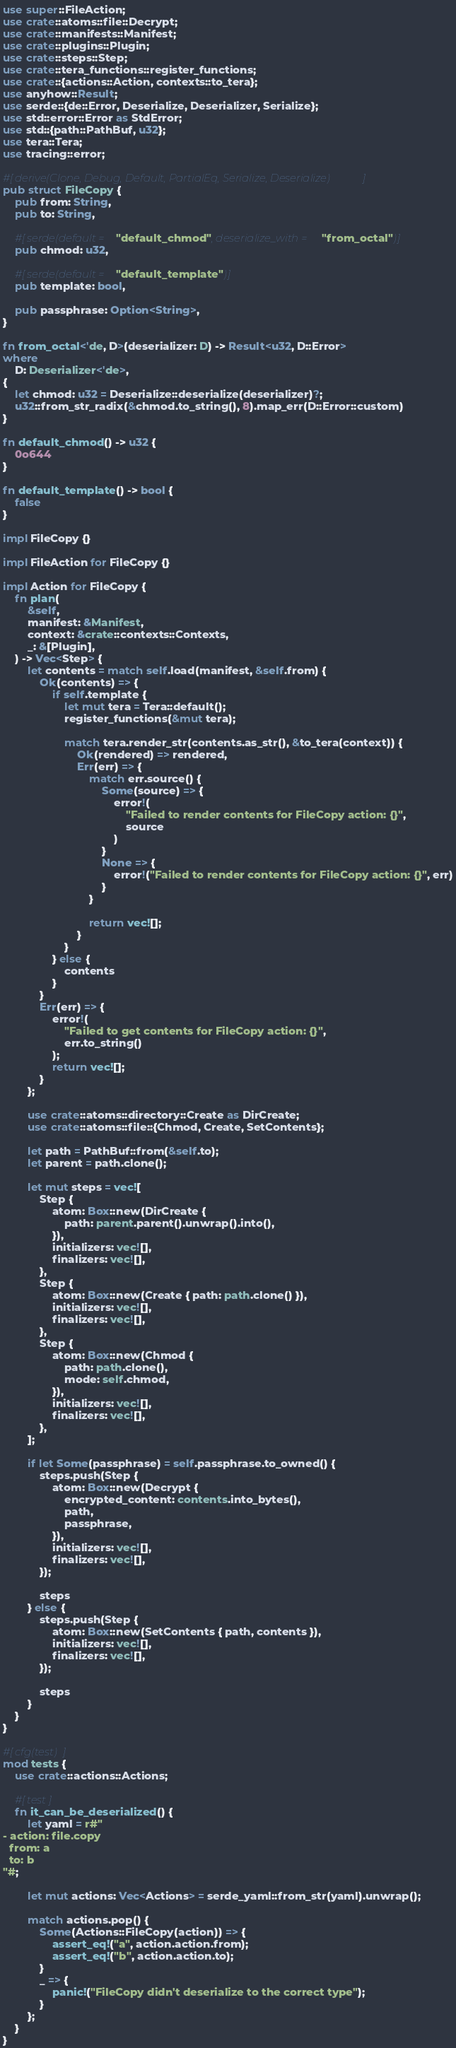Convert code to text. <code><loc_0><loc_0><loc_500><loc_500><_Rust_>use super::FileAction;
use crate::atoms::file::Decrypt;
use crate::manifests::Manifest;
use crate::plugins::Plugin;
use crate::steps::Step;
use crate::tera_functions::register_functions;
use crate::{actions::Action, contexts::to_tera};
use anyhow::Result;
use serde::{de::Error, Deserialize, Deserializer, Serialize};
use std::error::Error as StdError;
use std::{path::PathBuf, u32};
use tera::Tera;
use tracing::error;

#[derive(Clone, Debug, Default, PartialEq, Serialize, Deserialize)]
pub struct FileCopy {
    pub from: String,
    pub to: String,

    #[serde(default = "default_chmod", deserialize_with = "from_octal")]
    pub chmod: u32,

    #[serde(default = "default_template")]
    pub template: bool,

    pub passphrase: Option<String>,
}

fn from_octal<'de, D>(deserializer: D) -> Result<u32, D::Error>
where
    D: Deserializer<'de>,
{
    let chmod: u32 = Deserialize::deserialize(deserializer)?;
    u32::from_str_radix(&chmod.to_string(), 8).map_err(D::Error::custom)
}

fn default_chmod() -> u32 {
    0o644
}

fn default_template() -> bool {
    false
}

impl FileCopy {}

impl FileAction for FileCopy {}

impl Action for FileCopy {
    fn plan(
        &self,
        manifest: &Manifest,
        context: &crate::contexts::Contexts,
        _: &[Plugin],
    ) -> Vec<Step> {
        let contents = match self.load(manifest, &self.from) {
            Ok(contents) => {
                if self.template {
                    let mut tera = Tera::default();
                    register_functions(&mut tera);

                    match tera.render_str(contents.as_str(), &to_tera(context)) {
                        Ok(rendered) => rendered,
                        Err(err) => {
                            match err.source() {
                                Some(source) => {
                                    error!(
                                        "Failed to render contents for FileCopy action: {}",
                                        source
                                    )
                                }
                                None => {
                                    error!("Failed to render contents for FileCopy action: {}", err)
                                }
                            }

                            return vec![];
                        }
                    }
                } else {
                    contents
                }
            }
            Err(err) => {
                error!(
                    "Failed to get contents for FileCopy action: {}",
                    err.to_string()
                );
                return vec![];
            }
        };

        use crate::atoms::directory::Create as DirCreate;
        use crate::atoms::file::{Chmod, Create, SetContents};

        let path = PathBuf::from(&self.to);
        let parent = path.clone();

        let mut steps = vec![
            Step {
                atom: Box::new(DirCreate {
                    path: parent.parent().unwrap().into(),
                }),
                initializers: vec![],
                finalizers: vec![],
            },
            Step {
                atom: Box::new(Create { path: path.clone() }),
                initializers: vec![],
                finalizers: vec![],
            },
            Step {
                atom: Box::new(Chmod {
                    path: path.clone(),
                    mode: self.chmod,
                }),
                initializers: vec![],
                finalizers: vec![],
            },
        ];

        if let Some(passphrase) = self.passphrase.to_owned() {
            steps.push(Step {
                atom: Box::new(Decrypt {
                    encrypted_content: contents.into_bytes(),
                    path,
                    passphrase,
                }),
                initializers: vec![],
                finalizers: vec![],
            });

            steps
        } else {
            steps.push(Step {
                atom: Box::new(SetContents { path, contents }),
                initializers: vec![],
                finalizers: vec![],
            });

            steps
        }
    }
}

#[cfg(test)]
mod tests {
    use crate::actions::Actions;

    #[test]
    fn it_can_be_deserialized() {
        let yaml = r#"
- action: file.copy
  from: a
  to: b
"#;

        let mut actions: Vec<Actions> = serde_yaml::from_str(yaml).unwrap();

        match actions.pop() {
            Some(Actions::FileCopy(action)) => {
                assert_eq!("a", action.action.from);
                assert_eq!("b", action.action.to);
            }
            _ => {
                panic!("FileCopy didn't deserialize to the correct type");
            }
        };
    }
}
</code> 